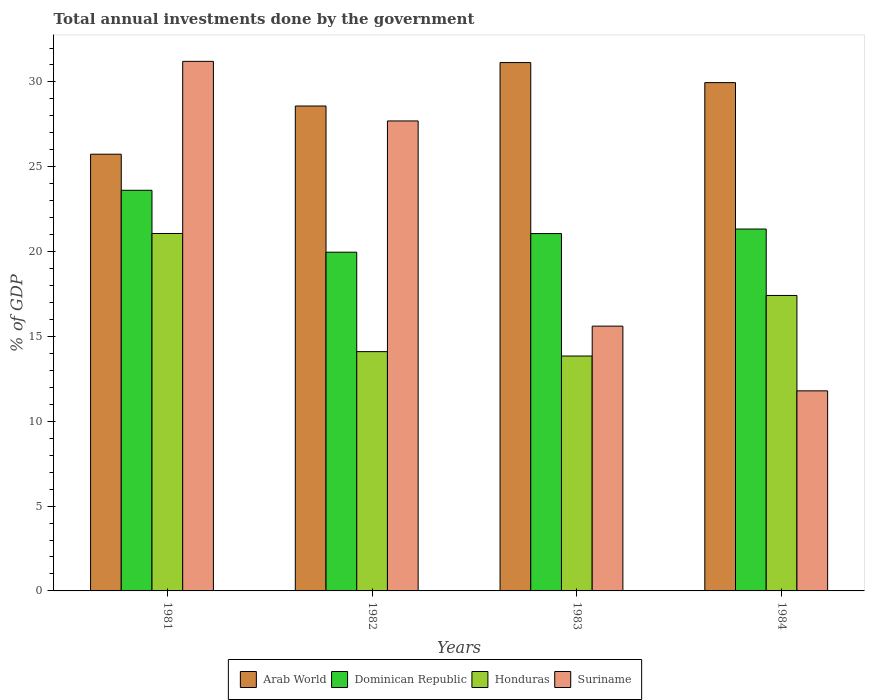How many different coloured bars are there?
Offer a very short reply. 4. How many groups of bars are there?
Keep it short and to the point. 4. How many bars are there on the 2nd tick from the left?
Give a very brief answer. 4. How many bars are there on the 2nd tick from the right?
Keep it short and to the point. 4. What is the total annual investments done by the government in Arab World in 1983?
Give a very brief answer. 31.14. Across all years, what is the maximum total annual investments done by the government in Arab World?
Offer a very short reply. 31.14. Across all years, what is the minimum total annual investments done by the government in Dominican Republic?
Your answer should be compact. 19.96. In which year was the total annual investments done by the government in Suriname minimum?
Provide a succinct answer. 1984. What is the total total annual investments done by the government in Arab World in the graph?
Your answer should be very brief. 115.42. What is the difference between the total annual investments done by the government in Suriname in 1981 and that in 1982?
Ensure brevity in your answer.  3.51. What is the difference between the total annual investments done by the government in Honduras in 1981 and the total annual investments done by the government in Dominican Republic in 1984?
Your response must be concise. -0.26. What is the average total annual investments done by the government in Arab World per year?
Your response must be concise. 28.86. In the year 1982, what is the difference between the total annual investments done by the government in Arab World and total annual investments done by the government in Honduras?
Keep it short and to the point. 14.48. In how many years, is the total annual investments done by the government in Arab World greater than 27 %?
Offer a very short reply. 3. What is the ratio of the total annual investments done by the government in Arab World in 1983 to that in 1984?
Ensure brevity in your answer.  1.04. Is the difference between the total annual investments done by the government in Arab World in 1982 and 1984 greater than the difference between the total annual investments done by the government in Honduras in 1982 and 1984?
Provide a succinct answer. Yes. What is the difference between the highest and the second highest total annual investments done by the government in Dominican Republic?
Offer a very short reply. 2.28. What is the difference between the highest and the lowest total annual investments done by the government in Honduras?
Make the answer very short. 7.22. Is the sum of the total annual investments done by the government in Suriname in 1981 and 1983 greater than the maximum total annual investments done by the government in Dominican Republic across all years?
Offer a terse response. Yes. What does the 4th bar from the left in 1982 represents?
Offer a terse response. Suriname. What does the 1st bar from the right in 1983 represents?
Your answer should be compact. Suriname. Are all the bars in the graph horizontal?
Give a very brief answer. No. Are the values on the major ticks of Y-axis written in scientific E-notation?
Give a very brief answer. No. Does the graph contain any zero values?
Give a very brief answer. No. How many legend labels are there?
Make the answer very short. 4. How are the legend labels stacked?
Keep it short and to the point. Horizontal. What is the title of the graph?
Your answer should be compact. Total annual investments done by the government. What is the label or title of the X-axis?
Your answer should be compact. Years. What is the label or title of the Y-axis?
Ensure brevity in your answer.  % of GDP. What is the % of GDP of Arab World in 1981?
Your response must be concise. 25.74. What is the % of GDP of Dominican Republic in 1981?
Your response must be concise. 23.61. What is the % of GDP of Honduras in 1981?
Your response must be concise. 21.07. What is the % of GDP of Suriname in 1981?
Provide a short and direct response. 31.21. What is the % of GDP of Arab World in 1982?
Provide a succinct answer. 28.58. What is the % of GDP in Dominican Republic in 1982?
Provide a short and direct response. 19.96. What is the % of GDP of Honduras in 1982?
Keep it short and to the point. 14.1. What is the % of GDP of Suriname in 1982?
Your response must be concise. 27.7. What is the % of GDP in Arab World in 1983?
Your answer should be compact. 31.14. What is the % of GDP in Dominican Republic in 1983?
Your answer should be compact. 21.06. What is the % of GDP of Honduras in 1983?
Offer a very short reply. 13.84. What is the % of GDP in Suriname in 1983?
Give a very brief answer. 15.61. What is the % of GDP of Arab World in 1984?
Provide a short and direct response. 29.96. What is the % of GDP in Dominican Republic in 1984?
Keep it short and to the point. 21.33. What is the % of GDP in Honduras in 1984?
Give a very brief answer. 17.41. What is the % of GDP of Suriname in 1984?
Your answer should be very brief. 11.79. Across all years, what is the maximum % of GDP in Arab World?
Your answer should be very brief. 31.14. Across all years, what is the maximum % of GDP of Dominican Republic?
Your answer should be very brief. 23.61. Across all years, what is the maximum % of GDP of Honduras?
Ensure brevity in your answer.  21.07. Across all years, what is the maximum % of GDP in Suriname?
Make the answer very short. 31.21. Across all years, what is the minimum % of GDP in Arab World?
Give a very brief answer. 25.74. Across all years, what is the minimum % of GDP of Dominican Republic?
Offer a very short reply. 19.96. Across all years, what is the minimum % of GDP of Honduras?
Provide a succinct answer. 13.84. Across all years, what is the minimum % of GDP in Suriname?
Your answer should be compact. 11.79. What is the total % of GDP of Arab World in the graph?
Give a very brief answer. 115.42. What is the total % of GDP in Dominican Republic in the graph?
Keep it short and to the point. 85.97. What is the total % of GDP of Honduras in the graph?
Provide a short and direct response. 66.43. What is the total % of GDP of Suriname in the graph?
Keep it short and to the point. 86.31. What is the difference between the % of GDP of Arab World in 1981 and that in 1982?
Keep it short and to the point. -2.84. What is the difference between the % of GDP of Dominican Republic in 1981 and that in 1982?
Provide a succinct answer. 3.65. What is the difference between the % of GDP in Honduras in 1981 and that in 1982?
Your response must be concise. 6.96. What is the difference between the % of GDP of Suriname in 1981 and that in 1982?
Provide a succinct answer. 3.51. What is the difference between the % of GDP in Arab World in 1981 and that in 1983?
Offer a very short reply. -5.4. What is the difference between the % of GDP in Dominican Republic in 1981 and that in 1983?
Your answer should be compact. 2.55. What is the difference between the % of GDP of Honduras in 1981 and that in 1983?
Provide a short and direct response. 7.22. What is the difference between the % of GDP in Suriname in 1981 and that in 1983?
Offer a terse response. 15.61. What is the difference between the % of GDP of Arab World in 1981 and that in 1984?
Your answer should be compact. -4.22. What is the difference between the % of GDP of Dominican Republic in 1981 and that in 1984?
Provide a short and direct response. 2.28. What is the difference between the % of GDP in Honduras in 1981 and that in 1984?
Provide a short and direct response. 3.65. What is the difference between the % of GDP of Suriname in 1981 and that in 1984?
Offer a terse response. 19.42. What is the difference between the % of GDP of Arab World in 1982 and that in 1983?
Provide a succinct answer. -2.56. What is the difference between the % of GDP in Dominican Republic in 1982 and that in 1983?
Offer a very short reply. -1.1. What is the difference between the % of GDP of Honduras in 1982 and that in 1983?
Your answer should be compact. 0.26. What is the difference between the % of GDP in Suriname in 1982 and that in 1983?
Make the answer very short. 12.09. What is the difference between the % of GDP in Arab World in 1982 and that in 1984?
Your answer should be very brief. -1.38. What is the difference between the % of GDP of Dominican Republic in 1982 and that in 1984?
Offer a very short reply. -1.36. What is the difference between the % of GDP of Honduras in 1982 and that in 1984?
Ensure brevity in your answer.  -3.31. What is the difference between the % of GDP in Suriname in 1982 and that in 1984?
Offer a terse response. 15.91. What is the difference between the % of GDP in Arab World in 1983 and that in 1984?
Make the answer very short. 1.18. What is the difference between the % of GDP in Dominican Republic in 1983 and that in 1984?
Give a very brief answer. -0.27. What is the difference between the % of GDP of Honduras in 1983 and that in 1984?
Provide a short and direct response. -3.57. What is the difference between the % of GDP of Suriname in 1983 and that in 1984?
Make the answer very short. 3.81. What is the difference between the % of GDP of Arab World in 1981 and the % of GDP of Dominican Republic in 1982?
Offer a very short reply. 5.77. What is the difference between the % of GDP of Arab World in 1981 and the % of GDP of Honduras in 1982?
Offer a terse response. 11.64. What is the difference between the % of GDP of Arab World in 1981 and the % of GDP of Suriname in 1982?
Ensure brevity in your answer.  -1.96. What is the difference between the % of GDP in Dominican Republic in 1981 and the % of GDP in Honduras in 1982?
Keep it short and to the point. 9.51. What is the difference between the % of GDP of Dominican Republic in 1981 and the % of GDP of Suriname in 1982?
Offer a terse response. -4.09. What is the difference between the % of GDP in Honduras in 1981 and the % of GDP in Suriname in 1982?
Your answer should be compact. -6.63. What is the difference between the % of GDP in Arab World in 1981 and the % of GDP in Dominican Republic in 1983?
Make the answer very short. 4.68. What is the difference between the % of GDP of Arab World in 1981 and the % of GDP of Honduras in 1983?
Give a very brief answer. 11.9. What is the difference between the % of GDP of Arab World in 1981 and the % of GDP of Suriname in 1983?
Ensure brevity in your answer.  10.13. What is the difference between the % of GDP of Dominican Republic in 1981 and the % of GDP of Honduras in 1983?
Offer a very short reply. 9.77. What is the difference between the % of GDP of Dominican Republic in 1981 and the % of GDP of Suriname in 1983?
Keep it short and to the point. 8.01. What is the difference between the % of GDP in Honduras in 1981 and the % of GDP in Suriname in 1983?
Make the answer very short. 5.46. What is the difference between the % of GDP of Arab World in 1981 and the % of GDP of Dominican Republic in 1984?
Offer a very short reply. 4.41. What is the difference between the % of GDP of Arab World in 1981 and the % of GDP of Honduras in 1984?
Ensure brevity in your answer.  8.32. What is the difference between the % of GDP in Arab World in 1981 and the % of GDP in Suriname in 1984?
Provide a succinct answer. 13.95. What is the difference between the % of GDP in Dominican Republic in 1981 and the % of GDP in Honduras in 1984?
Your answer should be very brief. 6.2. What is the difference between the % of GDP in Dominican Republic in 1981 and the % of GDP in Suriname in 1984?
Provide a succinct answer. 11.82. What is the difference between the % of GDP of Honduras in 1981 and the % of GDP of Suriname in 1984?
Your response must be concise. 9.28. What is the difference between the % of GDP in Arab World in 1982 and the % of GDP in Dominican Republic in 1983?
Your response must be concise. 7.52. What is the difference between the % of GDP in Arab World in 1982 and the % of GDP in Honduras in 1983?
Your answer should be very brief. 14.74. What is the difference between the % of GDP in Arab World in 1982 and the % of GDP in Suriname in 1983?
Keep it short and to the point. 12.97. What is the difference between the % of GDP in Dominican Republic in 1982 and the % of GDP in Honduras in 1983?
Provide a succinct answer. 6.12. What is the difference between the % of GDP of Dominican Republic in 1982 and the % of GDP of Suriname in 1983?
Ensure brevity in your answer.  4.36. What is the difference between the % of GDP of Honduras in 1982 and the % of GDP of Suriname in 1983?
Make the answer very short. -1.5. What is the difference between the % of GDP in Arab World in 1982 and the % of GDP in Dominican Republic in 1984?
Your answer should be compact. 7.25. What is the difference between the % of GDP of Arab World in 1982 and the % of GDP of Honduras in 1984?
Ensure brevity in your answer.  11.17. What is the difference between the % of GDP in Arab World in 1982 and the % of GDP in Suriname in 1984?
Provide a succinct answer. 16.79. What is the difference between the % of GDP in Dominican Republic in 1982 and the % of GDP in Honduras in 1984?
Keep it short and to the point. 2.55. What is the difference between the % of GDP of Dominican Republic in 1982 and the % of GDP of Suriname in 1984?
Keep it short and to the point. 8.17. What is the difference between the % of GDP of Honduras in 1982 and the % of GDP of Suriname in 1984?
Your response must be concise. 2.31. What is the difference between the % of GDP of Arab World in 1983 and the % of GDP of Dominican Republic in 1984?
Offer a terse response. 9.81. What is the difference between the % of GDP of Arab World in 1983 and the % of GDP of Honduras in 1984?
Provide a succinct answer. 13.73. What is the difference between the % of GDP of Arab World in 1983 and the % of GDP of Suriname in 1984?
Give a very brief answer. 19.35. What is the difference between the % of GDP in Dominican Republic in 1983 and the % of GDP in Honduras in 1984?
Offer a very short reply. 3.65. What is the difference between the % of GDP of Dominican Republic in 1983 and the % of GDP of Suriname in 1984?
Offer a very short reply. 9.27. What is the difference between the % of GDP in Honduras in 1983 and the % of GDP in Suriname in 1984?
Keep it short and to the point. 2.05. What is the average % of GDP in Arab World per year?
Your response must be concise. 28.86. What is the average % of GDP in Dominican Republic per year?
Keep it short and to the point. 21.49. What is the average % of GDP in Honduras per year?
Make the answer very short. 16.61. What is the average % of GDP of Suriname per year?
Keep it short and to the point. 21.58. In the year 1981, what is the difference between the % of GDP of Arab World and % of GDP of Dominican Republic?
Provide a succinct answer. 2.13. In the year 1981, what is the difference between the % of GDP of Arab World and % of GDP of Honduras?
Keep it short and to the point. 4.67. In the year 1981, what is the difference between the % of GDP of Arab World and % of GDP of Suriname?
Provide a short and direct response. -5.47. In the year 1981, what is the difference between the % of GDP in Dominican Republic and % of GDP in Honduras?
Your answer should be very brief. 2.55. In the year 1981, what is the difference between the % of GDP in Dominican Republic and % of GDP in Suriname?
Your response must be concise. -7.6. In the year 1981, what is the difference between the % of GDP of Honduras and % of GDP of Suriname?
Keep it short and to the point. -10.15. In the year 1982, what is the difference between the % of GDP of Arab World and % of GDP of Dominican Republic?
Keep it short and to the point. 8.62. In the year 1982, what is the difference between the % of GDP of Arab World and % of GDP of Honduras?
Your answer should be very brief. 14.48. In the year 1982, what is the difference between the % of GDP of Arab World and % of GDP of Suriname?
Keep it short and to the point. 0.88. In the year 1982, what is the difference between the % of GDP of Dominican Republic and % of GDP of Honduras?
Make the answer very short. 5.86. In the year 1982, what is the difference between the % of GDP in Dominican Republic and % of GDP in Suriname?
Offer a terse response. -7.74. In the year 1982, what is the difference between the % of GDP in Honduras and % of GDP in Suriname?
Your answer should be compact. -13.6. In the year 1983, what is the difference between the % of GDP of Arab World and % of GDP of Dominican Republic?
Keep it short and to the point. 10.08. In the year 1983, what is the difference between the % of GDP of Arab World and % of GDP of Honduras?
Keep it short and to the point. 17.3. In the year 1983, what is the difference between the % of GDP of Arab World and % of GDP of Suriname?
Provide a succinct answer. 15.53. In the year 1983, what is the difference between the % of GDP in Dominican Republic and % of GDP in Honduras?
Keep it short and to the point. 7.22. In the year 1983, what is the difference between the % of GDP of Dominican Republic and % of GDP of Suriname?
Give a very brief answer. 5.46. In the year 1983, what is the difference between the % of GDP in Honduras and % of GDP in Suriname?
Provide a succinct answer. -1.76. In the year 1984, what is the difference between the % of GDP of Arab World and % of GDP of Dominican Republic?
Offer a terse response. 8.63. In the year 1984, what is the difference between the % of GDP of Arab World and % of GDP of Honduras?
Your answer should be compact. 12.55. In the year 1984, what is the difference between the % of GDP in Arab World and % of GDP in Suriname?
Your answer should be compact. 18.17. In the year 1984, what is the difference between the % of GDP in Dominican Republic and % of GDP in Honduras?
Offer a terse response. 3.91. In the year 1984, what is the difference between the % of GDP in Dominican Republic and % of GDP in Suriname?
Keep it short and to the point. 9.54. In the year 1984, what is the difference between the % of GDP of Honduras and % of GDP of Suriname?
Keep it short and to the point. 5.62. What is the ratio of the % of GDP of Arab World in 1981 to that in 1982?
Your answer should be very brief. 0.9. What is the ratio of the % of GDP of Dominican Republic in 1981 to that in 1982?
Provide a succinct answer. 1.18. What is the ratio of the % of GDP of Honduras in 1981 to that in 1982?
Your response must be concise. 1.49. What is the ratio of the % of GDP in Suriname in 1981 to that in 1982?
Keep it short and to the point. 1.13. What is the ratio of the % of GDP in Arab World in 1981 to that in 1983?
Your response must be concise. 0.83. What is the ratio of the % of GDP of Dominican Republic in 1981 to that in 1983?
Your answer should be very brief. 1.12. What is the ratio of the % of GDP of Honduras in 1981 to that in 1983?
Your answer should be compact. 1.52. What is the ratio of the % of GDP in Arab World in 1981 to that in 1984?
Offer a very short reply. 0.86. What is the ratio of the % of GDP in Dominican Republic in 1981 to that in 1984?
Ensure brevity in your answer.  1.11. What is the ratio of the % of GDP of Honduras in 1981 to that in 1984?
Give a very brief answer. 1.21. What is the ratio of the % of GDP in Suriname in 1981 to that in 1984?
Your response must be concise. 2.65. What is the ratio of the % of GDP of Arab World in 1982 to that in 1983?
Your answer should be very brief. 0.92. What is the ratio of the % of GDP in Dominican Republic in 1982 to that in 1983?
Your answer should be very brief. 0.95. What is the ratio of the % of GDP in Honduras in 1982 to that in 1983?
Keep it short and to the point. 1.02. What is the ratio of the % of GDP in Suriname in 1982 to that in 1983?
Give a very brief answer. 1.77. What is the ratio of the % of GDP in Arab World in 1982 to that in 1984?
Give a very brief answer. 0.95. What is the ratio of the % of GDP in Dominican Republic in 1982 to that in 1984?
Offer a terse response. 0.94. What is the ratio of the % of GDP in Honduras in 1982 to that in 1984?
Provide a succinct answer. 0.81. What is the ratio of the % of GDP of Suriname in 1982 to that in 1984?
Make the answer very short. 2.35. What is the ratio of the % of GDP in Arab World in 1983 to that in 1984?
Provide a short and direct response. 1.04. What is the ratio of the % of GDP of Dominican Republic in 1983 to that in 1984?
Make the answer very short. 0.99. What is the ratio of the % of GDP of Honduras in 1983 to that in 1984?
Make the answer very short. 0.8. What is the ratio of the % of GDP of Suriname in 1983 to that in 1984?
Keep it short and to the point. 1.32. What is the difference between the highest and the second highest % of GDP of Arab World?
Ensure brevity in your answer.  1.18. What is the difference between the highest and the second highest % of GDP of Dominican Republic?
Your answer should be very brief. 2.28. What is the difference between the highest and the second highest % of GDP in Honduras?
Your answer should be very brief. 3.65. What is the difference between the highest and the second highest % of GDP in Suriname?
Your response must be concise. 3.51. What is the difference between the highest and the lowest % of GDP in Arab World?
Your response must be concise. 5.4. What is the difference between the highest and the lowest % of GDP in Dominican Republic?
Your answer should be compact. 3.65. What is the difference between the highest and the lowest % of GDP in Honduras?
Provide a succinct answer. 7.22. What is the difference between the highest and the lowest % of GDP in Suriname?
Keep it short and to the point. 19.42. 